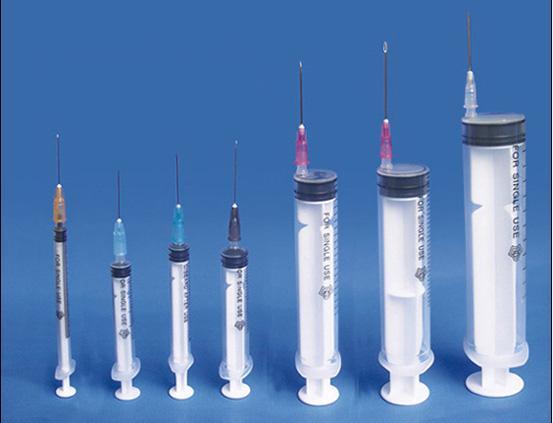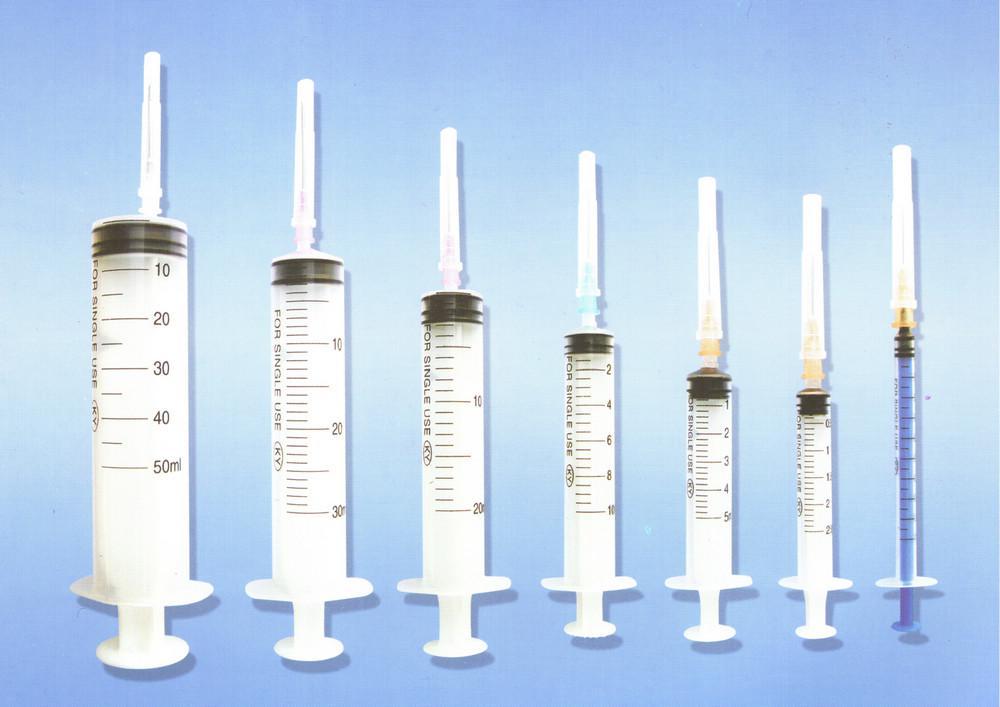The first image is the image on the left, the second image is the image on the right. Given the left and right images, does the statement "There are at least fourteen syringes with needle on them." hold true? Answer yes or no. Yes. The first image is the image on the left, the second image is the image on the right. For the images shown, is this caption "There are more than twelve syringes in total." true? Answer yes or no. Yes. 